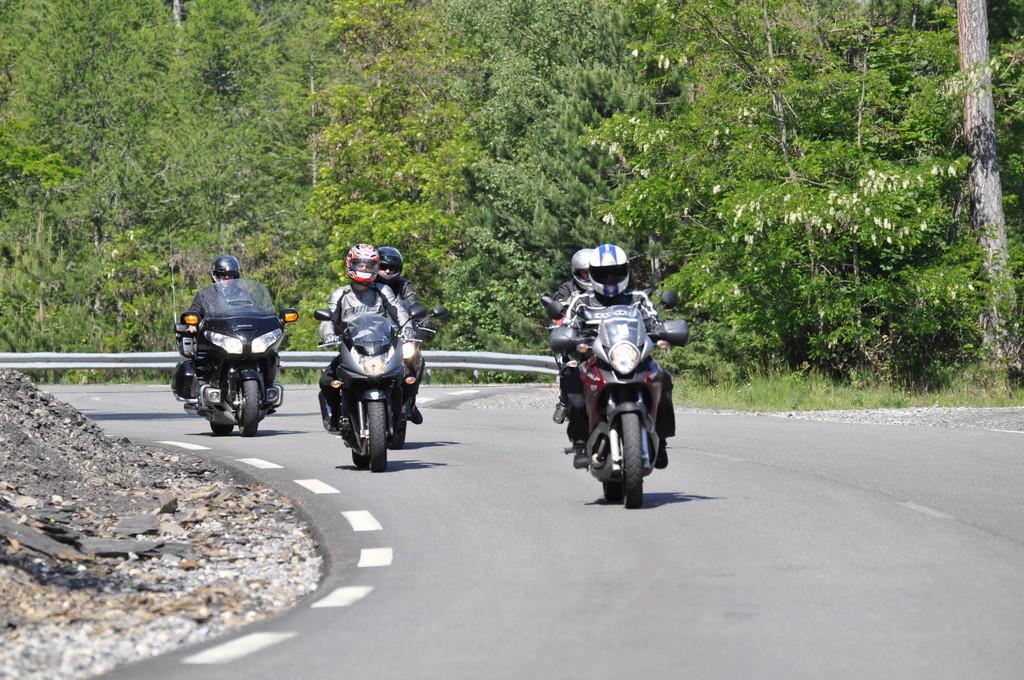Please provide a concise description of this image. In this image there are five people who are riding the bike on the road one behind the other. In the background there are trees. On the left side there are stones. There is a railing beside the road. 